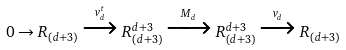Convert formula to latex. <formula><loc_0><loc_0><loc_500><loc_500>0 \to R _ { ( d + 3 ) } \xrightarrow { v _ { d } ^ { t } } R _ { ( d + 3 ) } ^ { d + 3 } \xrightarrow { M _ { d } } R _ { ( d + 3 ) } ^ { d + 3 } \xrightarrow { v _ { d } } R _ { ( d + 3 ) }</formula> 